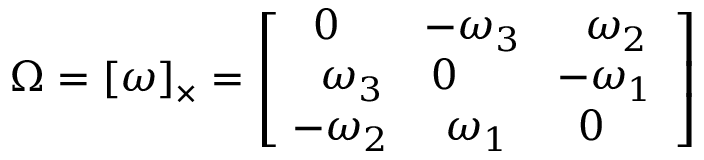Convert formula to latex. <formula><loc_0><loc_0><loc_500><loc_500>\Omega = [ \omega ] _ { \times } = { \left [ \begin{array} { l l l } { \, 0 } & { \, - \omega _ { 3 } } & { \, \omega _ { 2 } } \\ { \, \omega _ { 3 } } & { 0 } & { \, - \omega _ { 1 } } \\ { \, - \omega _ { 2 } } & { \, \omega _ { 1 } } & { \, 0 } \end{array} \right ] }</formula> 